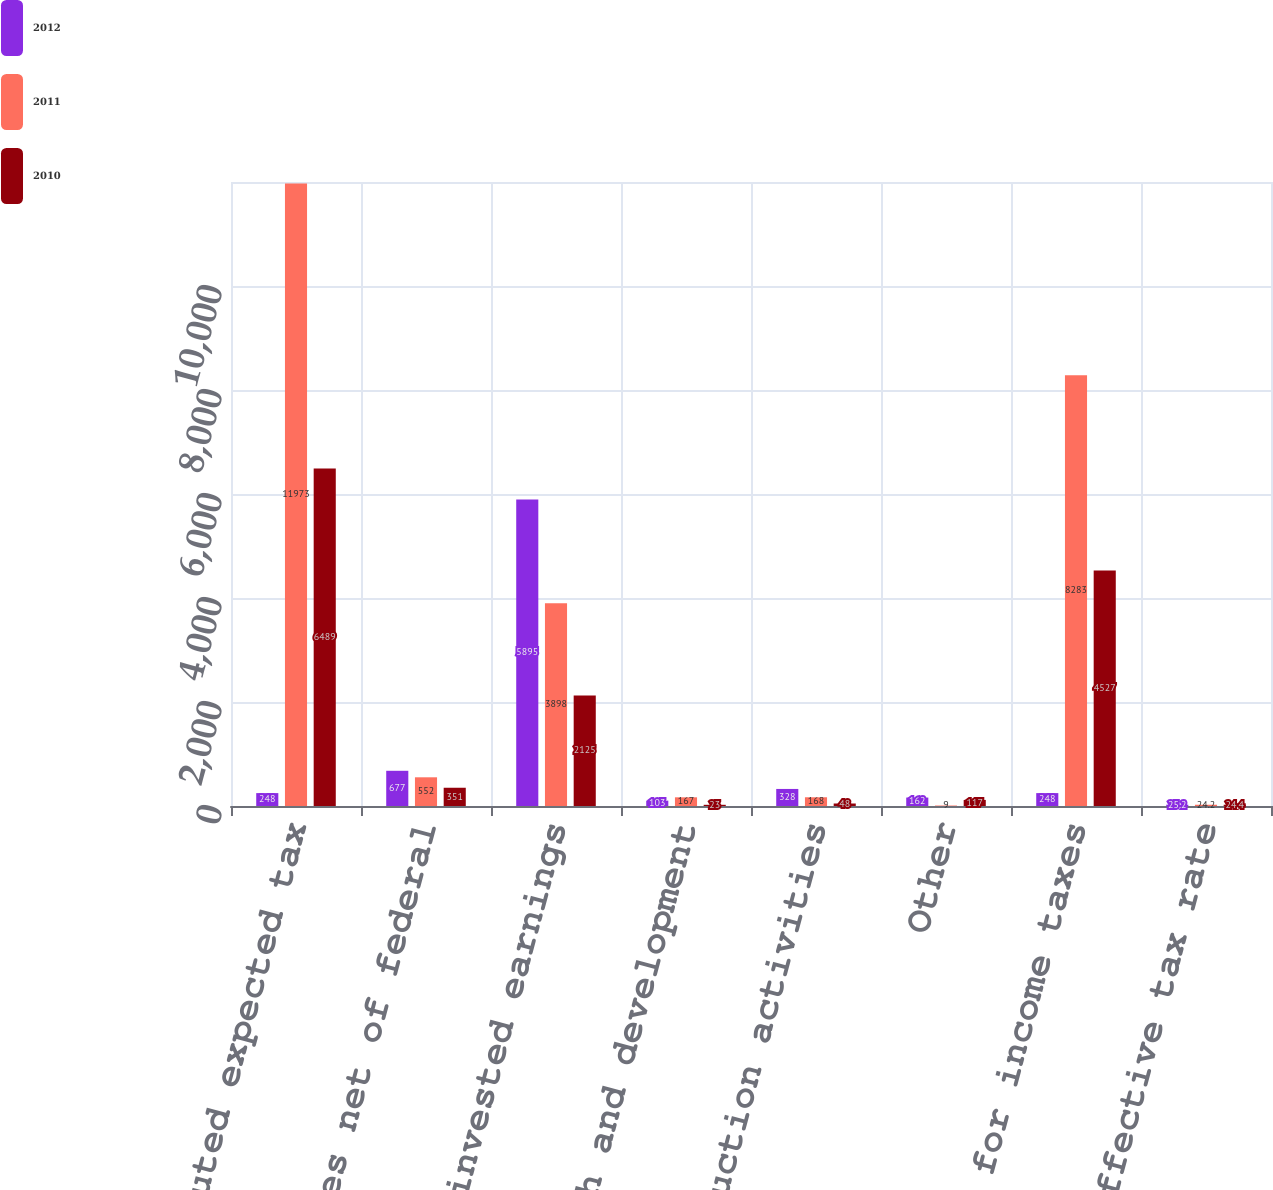Convert chart. <chart><loc_0><loc_0><loc_500><loc_500><stacked_bar_chart><ecel><fcel>Computed expected tax<fcel>State taxes net of federal<fcel>Indefinitely invested earnings<fcel>Research and development<fcel>Domestic production activities<fcel>Other<fcel>Provision for income taxes<fcel>Effective tax rate<nl><fcel>2012<fcel>248<fcel>677<fcel>5895<fcel>103<fcel>328<fcel>162<fcel>248<fcel>25.2<nl><fcel>2011<fcel>11973<fcel>552<fcel>3898<fcel>167<fcel>168<fcel>9<fcel>8283<fcel>24.2<nl><fcel>2010<fcel>6489<fcel>351<fcel>2125<fcel>23<fcel>48<fcel>117<fcel>4527<fcel>24.4<nl></chart> 